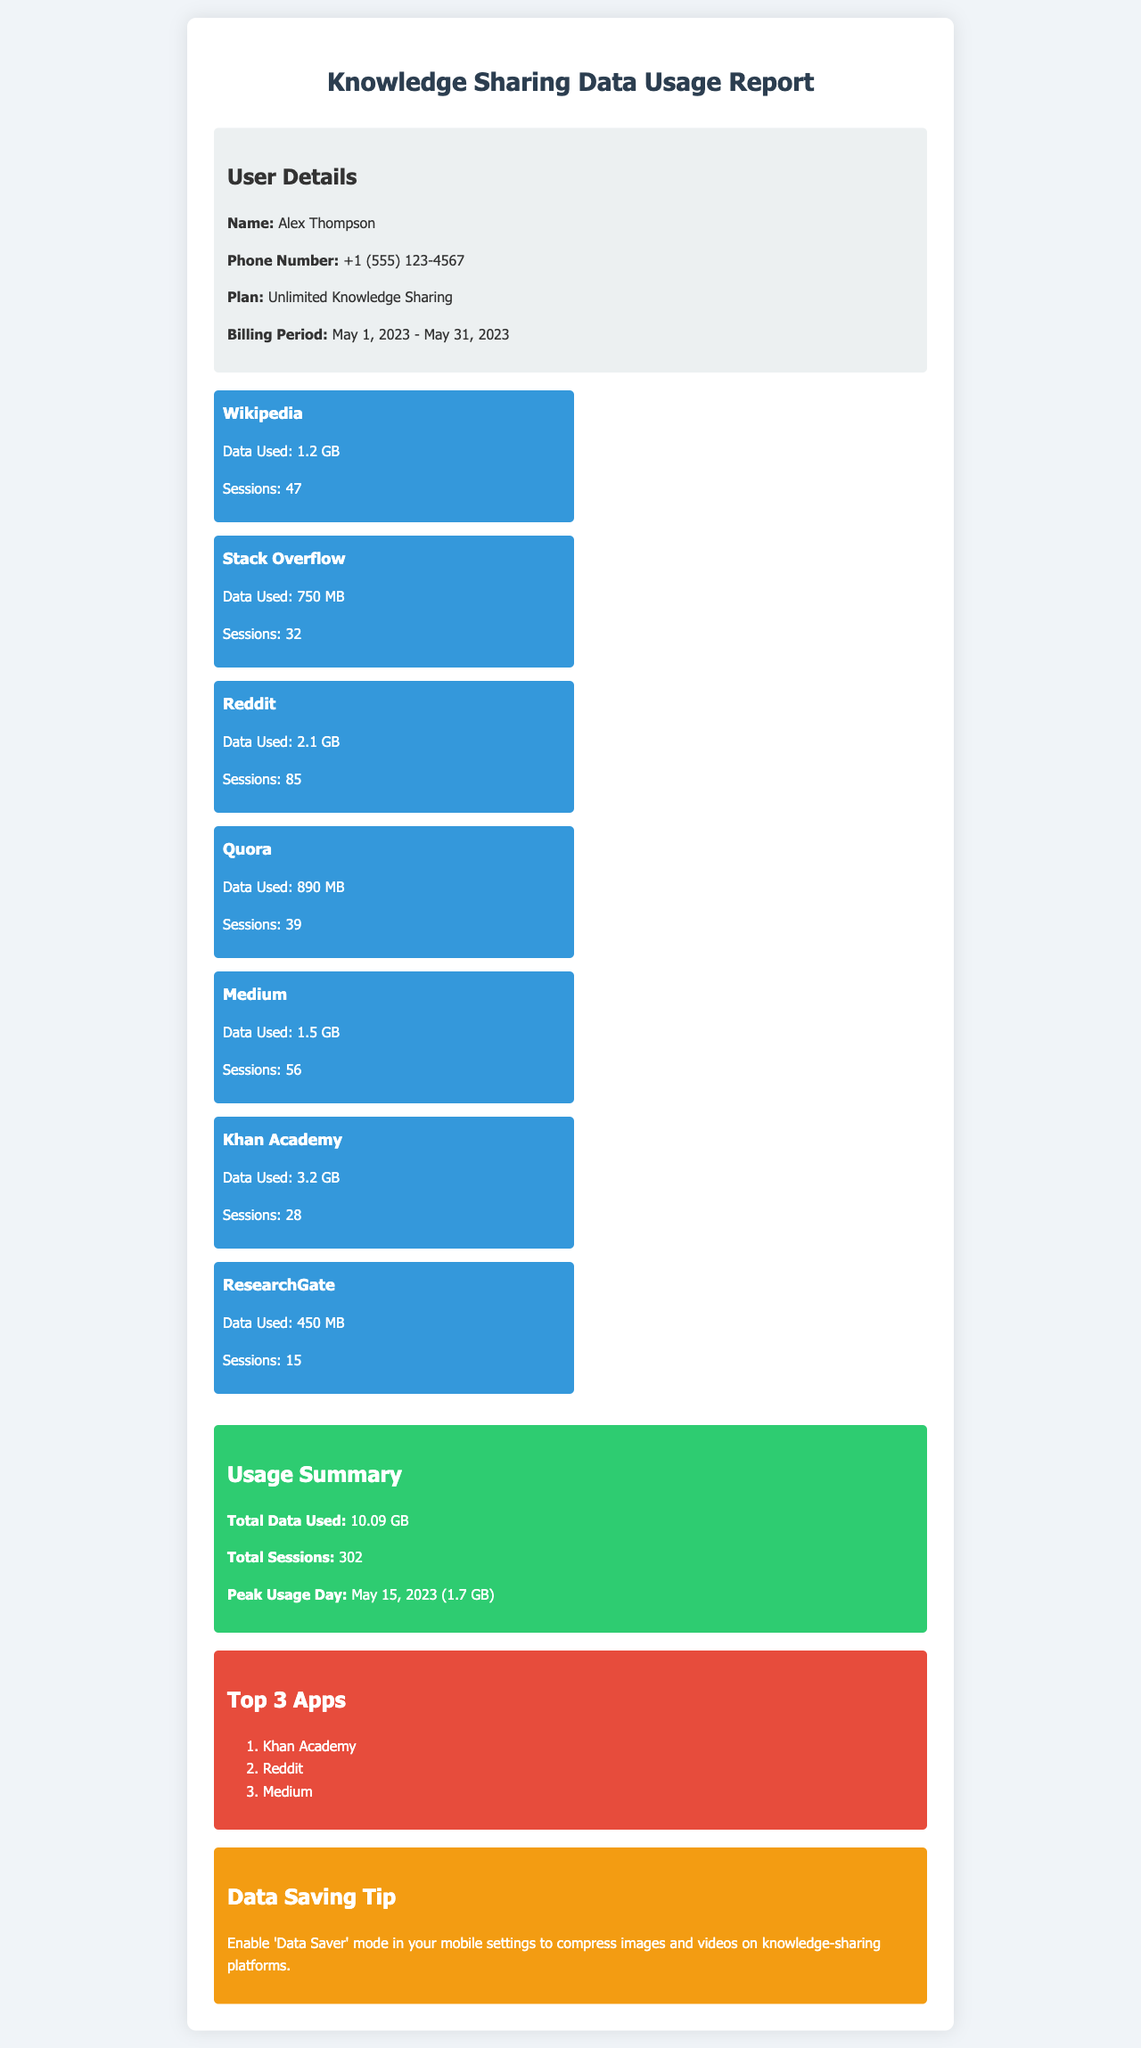what is the user name? The user name is located in the user details section at the top of the document.
Answer: Alex Thompson what is the phone number? The phone number is listed in the user details section of the document.
Answer: +1 (555) 123-4567 what is the total data used? Total data used is summarized at the bottom of the document under "Usage Summary."
Answer: 10.09 GB how many total sessions were recorded? The total sessions are provided in the summary section of the document.
Answer: 302 which app used the most data? By comparing the data used by each app in the data usage section, we can determine this information.
Answer: Khan Academy what was the peak usage day? This information is specified in the usage summary section of the document.
Answer: May 15, 2023 how many sessions did the user have on Reddit? The number of sessions for Reddit is listed in the data usage section.
Answer: 85 what is the recommended data saving tip? The data saving tip is mentioned towards the end of the document.
Answer: Enable 'Data Saver' mode what is the billing period for the user? The billing period is mentioned in the user details at the beginning of the document.
Answer: May 1, 2023 - May 31, 2023 how many apps are mentioned in the document? The document provides a list of apps in the data usage section that can be counted.
Answer: 7 